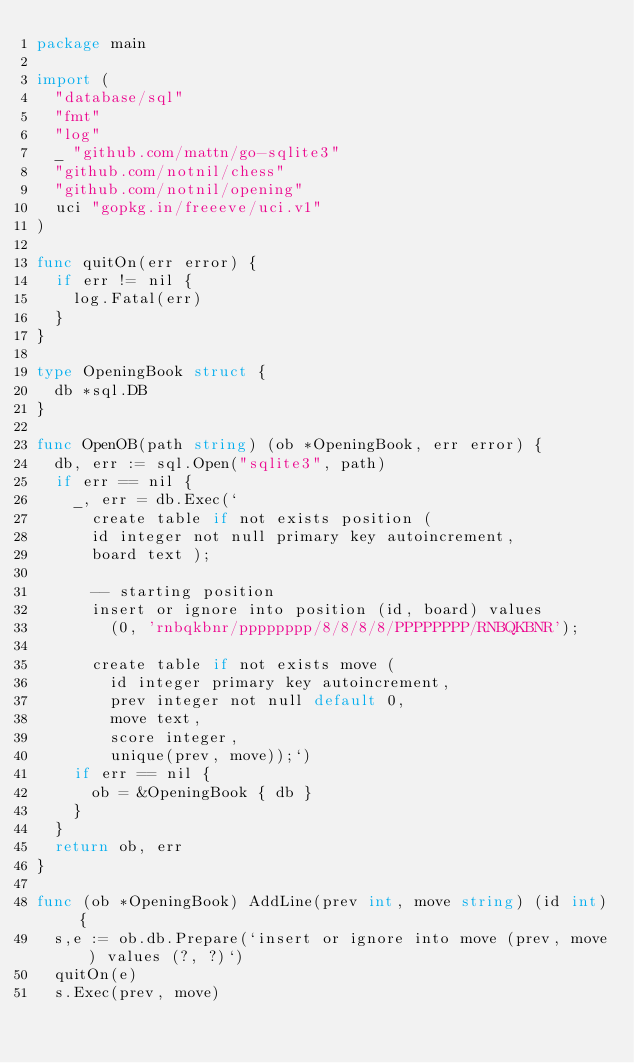<code> <loc_0><loc_0><loc_500><loc_500><_Go_>package main

import (
	"database/sql"
	"fmt"
	"log"
	_ "github.com/mattn/go-sqlite3"
	"github.com/notnil/chess"
	"github.com/notnil/opening"
	uci "gopkg.in/freeeve/uci.v1"
)

func quitOn(err error) {
	if err != nil {
		log.Fatal(err)
	}
}

type OpeningBook struct {
	db *sql.DB
}

func OpenOB(path string) (ob *OpeningBook, err error) {
	db, err := sql.Open("sqlite3", path)
	if err == nil {
		_, err = db.Exec(`
      create table if not exists position (
      id integer not null primary key autoincrement,
      board text );

      -- starting position
      insert or ignore into position (id, board) values
        (0, 'rnbqkbnr/pppppppp/8/8/8/8/PPPPPPPP/RNBQKBNR');

      create table if not exists move (
        id integer primary key autoincrement,
        prev integer not null default 0,
        move text,
        score integer,
        unique(prev, move));`)
		if err == nil {
			ob = &OpeningBook { db }
		}
	}
	return ob, err
}

func (ob *OpeningBook) AddLine(prev int, move string) (id int) {
	s,e := ob.db.Prepare(`insert or ignore into move (prev, move) values (?, ?)`)
	quitOn(e)
	s.Exec(prev, move)</code> 